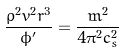Convert formula to latex. <formula><loc_0><loc_0><loc_500><loc_500>\frac { \rho ^ { 2 } v ^ { 2 } r ^ { 3 } } { \phi ^ { \prime } } = \frac { \dot { m } ^ { 2 } } { 4 \pi ^ { 2 } c _ { s } ^ { 2 } }</formula> 